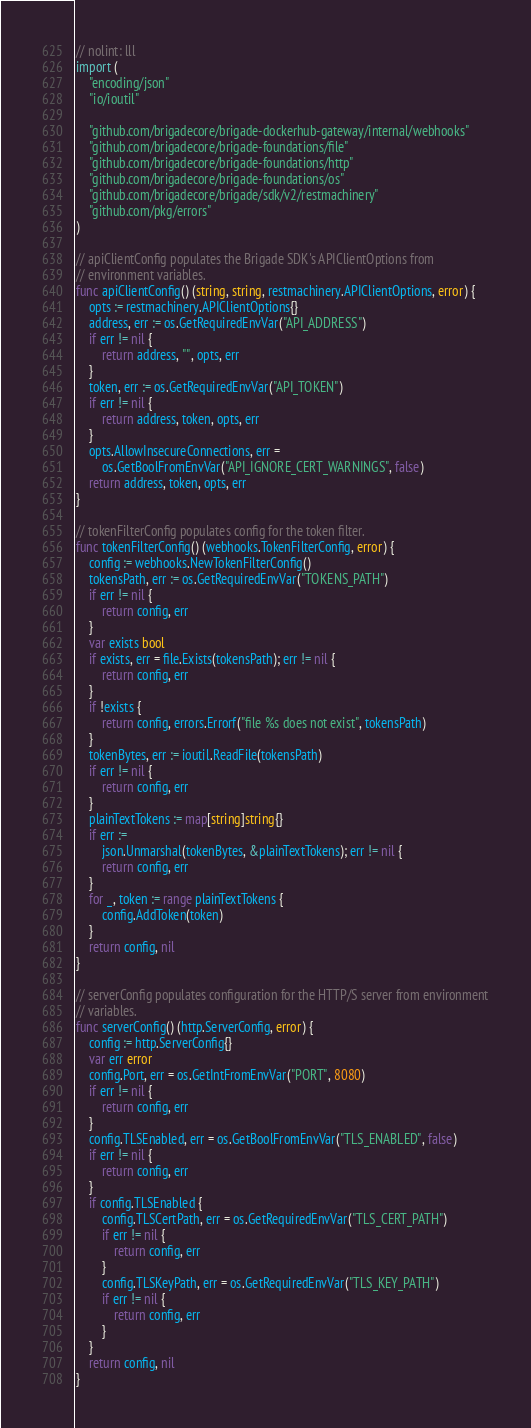Convert code to text. <code><loc_0><loc_0><loc_500><loc_500><_Go_>// nolint: lll
import (
	"encoding/json"
	"io/ioutil"

	"github.com/brigadecore/brigade-dockerhub-gateway/internal/webhooks"
	"github.com/brigadecore/brigade-foundations/file"
	"github.com/brigadecore/brigade-foundations/http"
	"github.com/brigadecore/brigade-foundations/os"
	"github.com/brigadecore/brigade/sdk/v2/restmachinery"
	"github.com/pkg/errors"
)

// apiClientConfig populates the Brigade SDK's APIClientOptions from
// environment variables.
func apiClientConfig() (string, string, restmachinery.APIClientOptions, error) {
	opts := restmachinery.APIClientOptions{}
	address, err := os.GetRequiredEnvVar("API_ADDRESS")
	if err != nil {
		return address, "", opts, err
	}
	token, err := os.GetRequiredEnvVar("API_TOKEN")
	if err != nil {
		return address, token, opts, err
	}
	opts.AllowInsecureConnections, err =
		os.GetBoolFromEnvVar("API_IGNORE_CERT_WARNINGS", false)
	return address, token, opts, err
}

// tokenFilterConfig populates config for the token filter.
func tokenFilterConfig() (webhooks.TokenFilterConfig, error) {
	config := webhooks.NewTokenFilterConfig()
	tokensPath, err := os.GetRequiredEnvVar("TOKENS_PATH")
	if err != nil {
		return config, err
	}
	var exists bool
	if exists, err = file.Exists(tokensPath); err != nil {
		return config, err
	}
	if !exists {
		return config, errors.Errorf("file %s does not exist", tokensPath)
	}
	tokenBytes, err := ioutil.ReadFile(tokensPath)
	if err != nil {
		return config, err
	}
	plainTextTokens := map[string]string{}
	if err :=
		json.Unmarshal(tokenBytes, &plainTextTokens); err != nil {
		return config, err
	}
	for _, token := range plainTextTokens {
		config.AddToken(token)
	}
	return config, nil
}

// serverConfig populates configuration for the HTTP/S server from environment
// variables.
func serverConfig() (http.ServerConfig, error) {
	config := http.ServerConfig{}
	var err error
	config.Port, err = os.GetIntFromEnvVar("PORT", 8080)
	if err != nil {
		return config, err
	}
	config.TLSEnabled, err = os.GetBoolFromEnvVar("TLS_ENABLED", false)
	if err != nil {
		return config, err
	}
	if config.TLSEnabled {
		config.TLSCertPath, err = os.GetRequiredEnvVar("TLS_CERT_PATH")
		if err != nil {
			return config, err
		}
		config.TLSKeyPath, err = os.GetRequiredEnvVar("TLS_KEY_PATH")
		if err != nil {
			return config, err
		}
	}
	return config, nil
}
</code> 